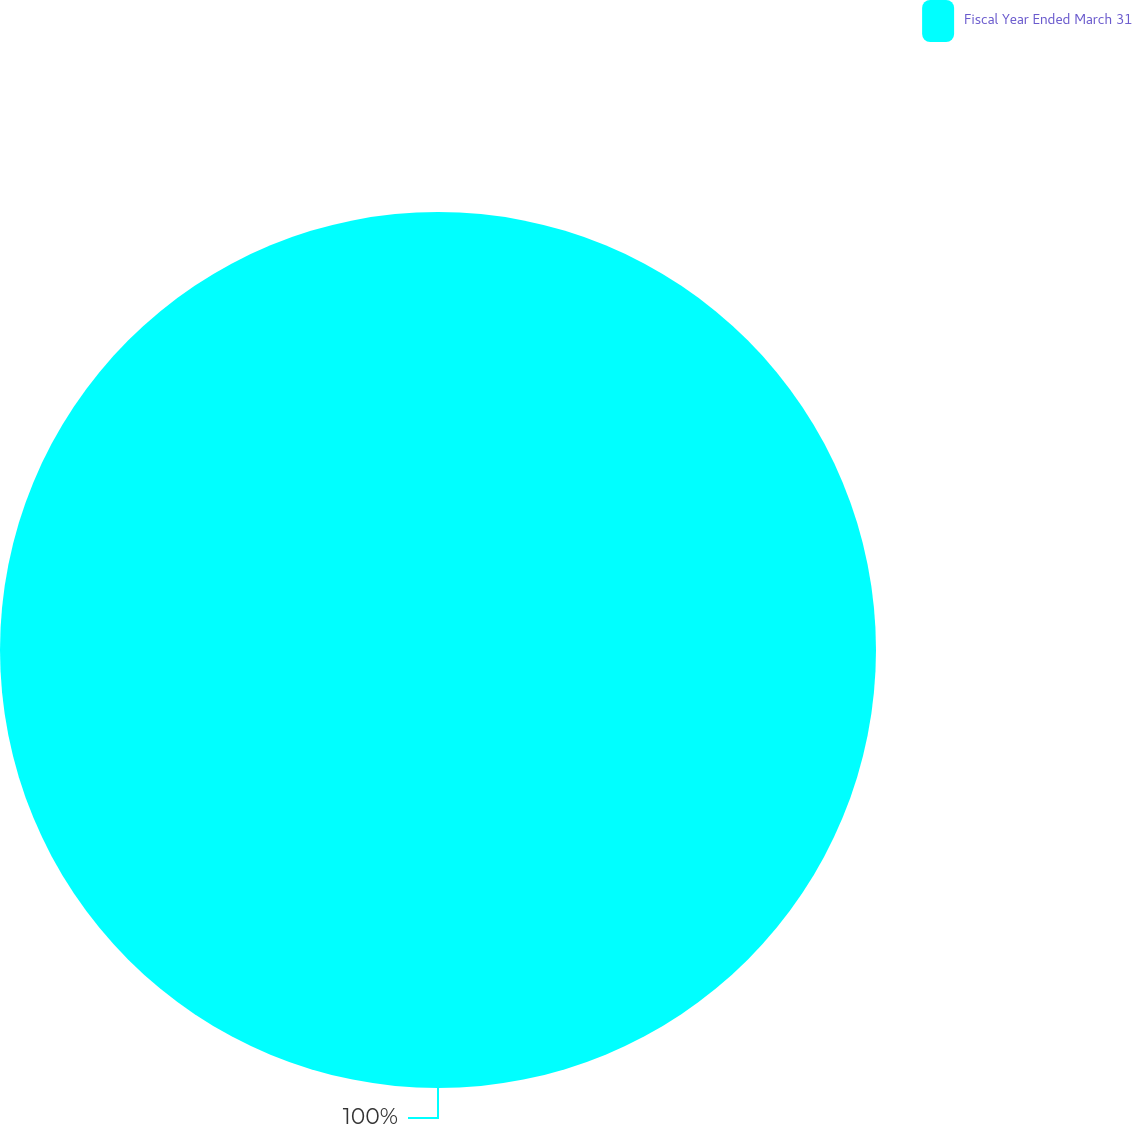Convert chart. <chart><loc_0><loc_0><loc_500><loc_500><pie_chart><fcel>Fiscal Year Ended March 31<nl><fcel>100.0%<nl></chart> 